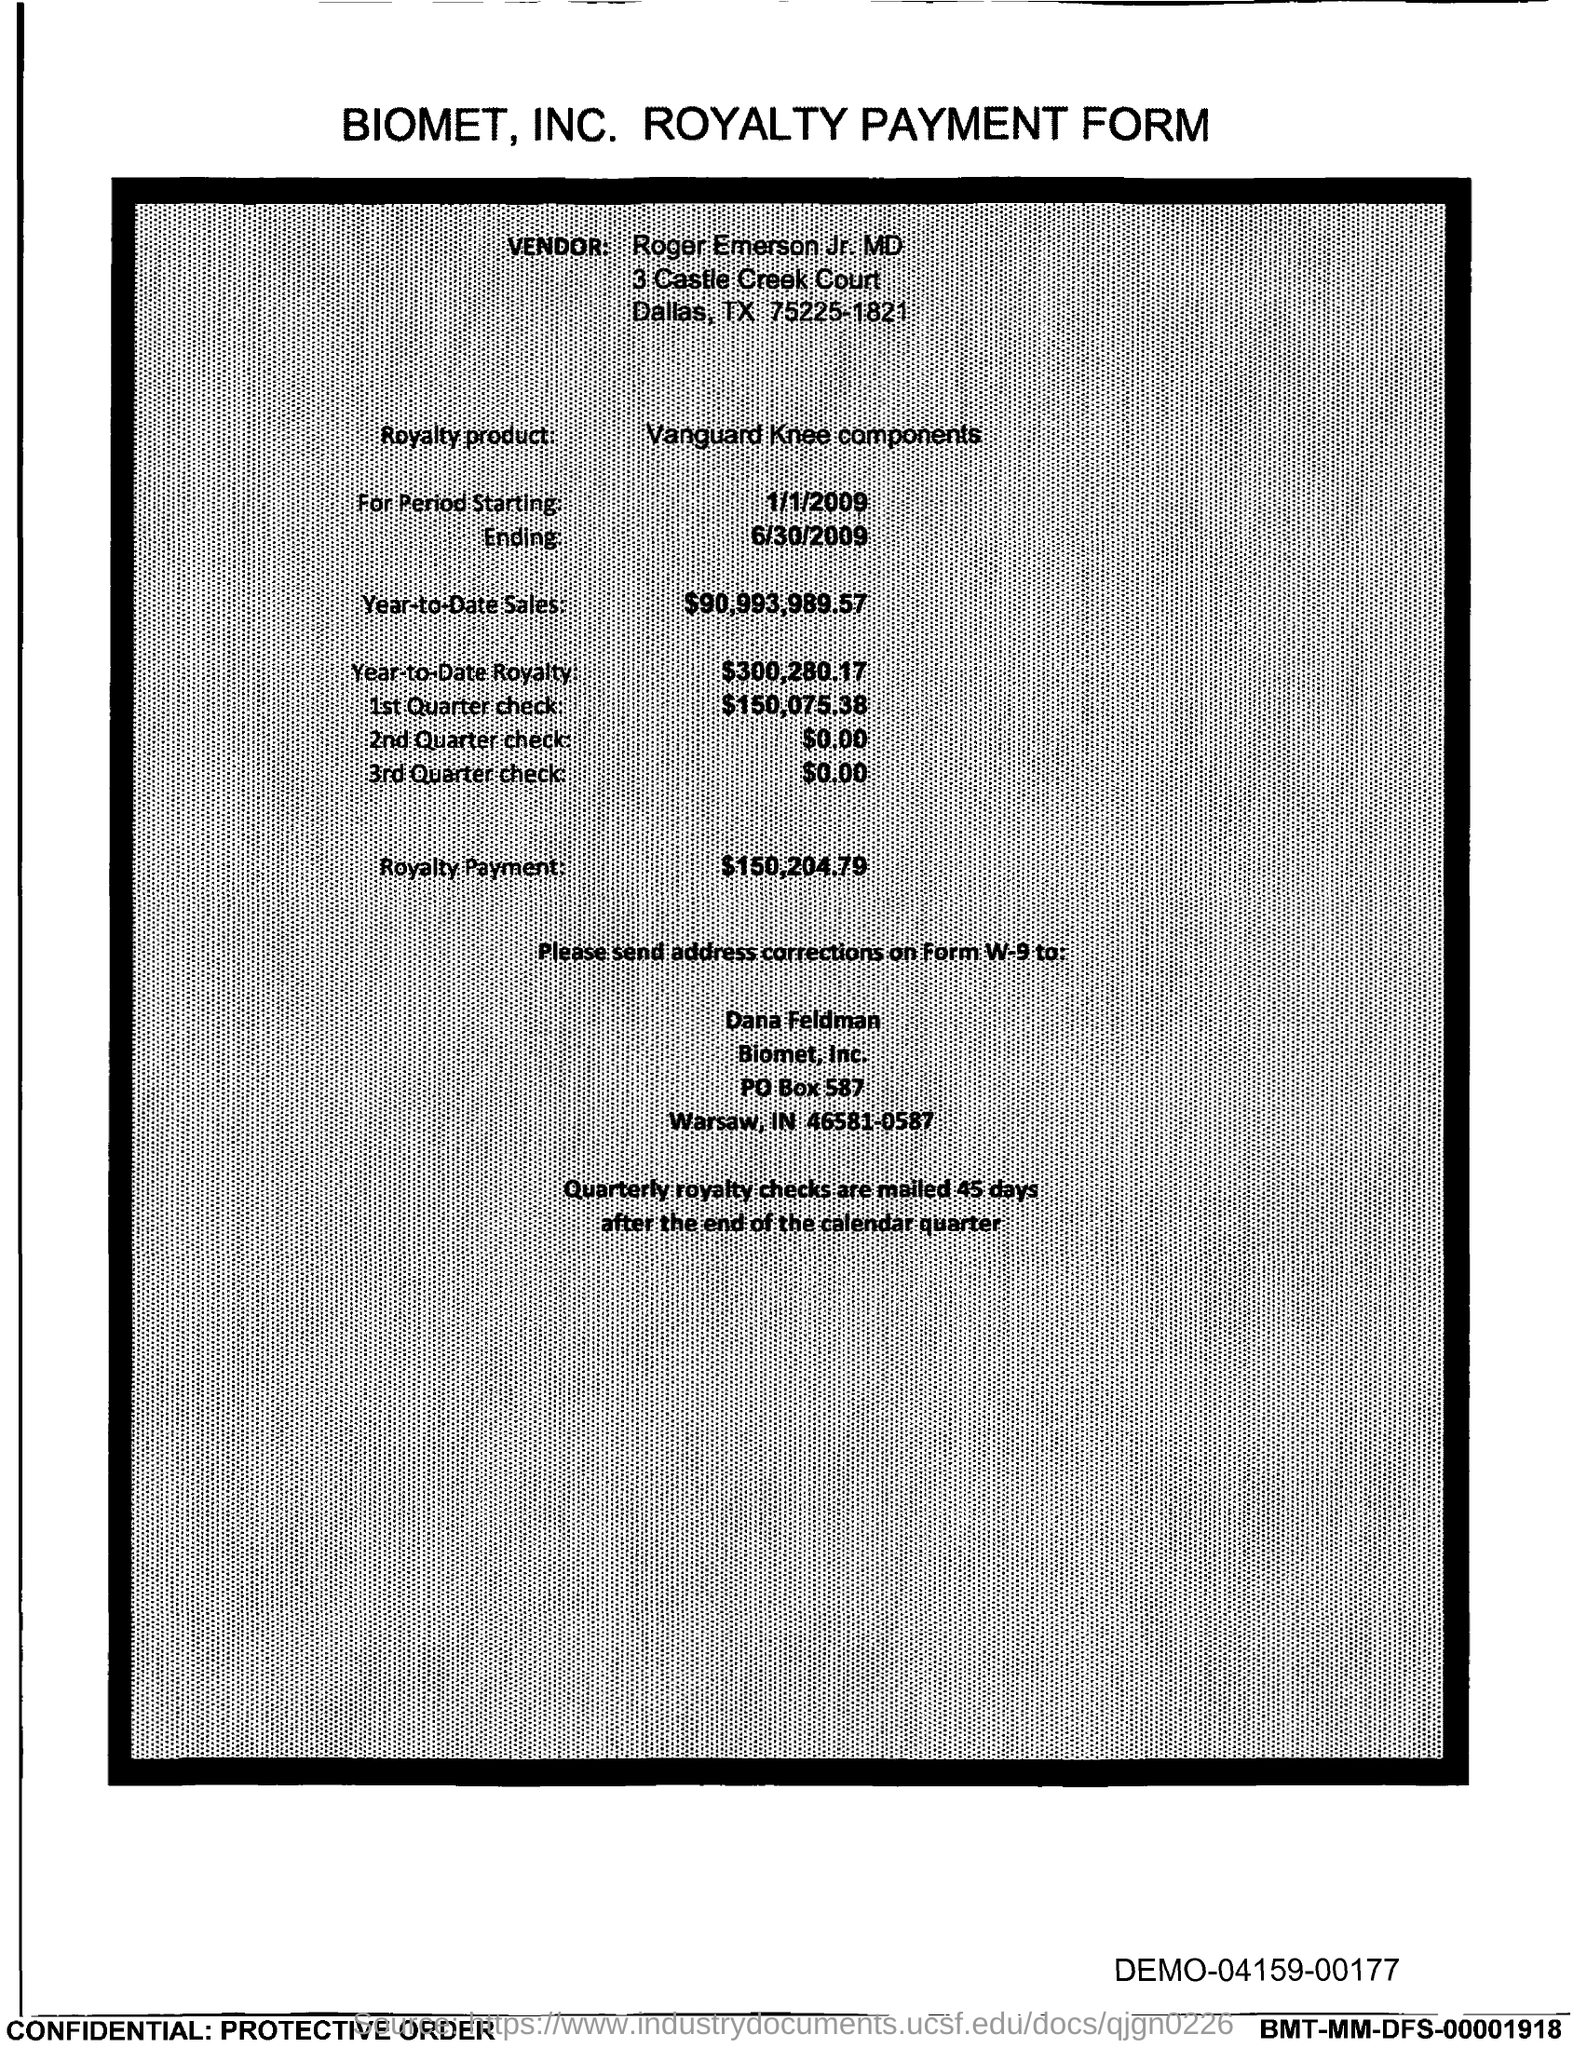Point out several critical features in this image. The amount noted on the form for the 1st quarter check is $150,075.38. The royalty payment for the product mentioned in the form is $150,204.79. The individual named Roger Emerson Jr., MD, was mentioned as the vendor in the form. The amount mentioned in the form for the 2nd Quarter check is $0.00. The end date of the royalty period is June 30, 2009. 